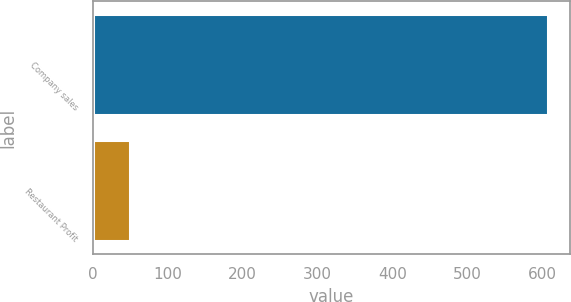<chart> <loc_0><loc_0><loc_500><loc_500><bar_chart><fcel>Company sales<fcel>Restaurant Profit<nl><fcel>607<fcel>50<nl></chart> 